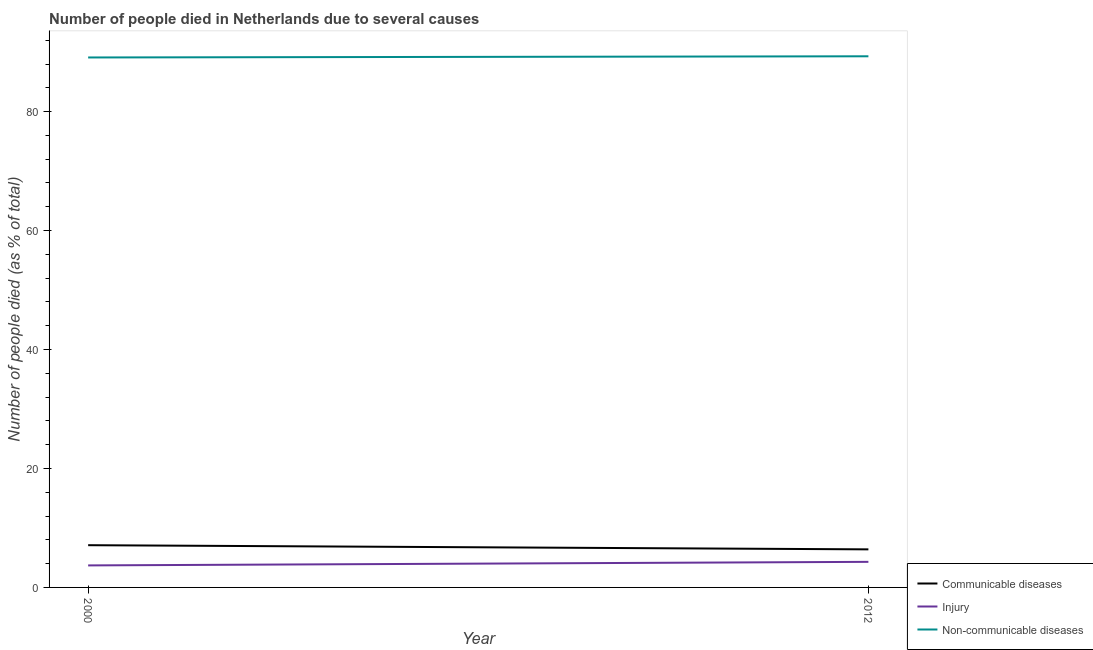How many different coloured lines are there?
Your response must be concise. 3. Is the number of lines equal to the number of legend labels?
Your response must be concise. Yes. Across all years, what is the maximum number of people who dies of non-communicable diseases?
Make the answer very short. 89.3. Across all years, what is the minimum number of people who dies of non-communicable diseases?
Give a very brief answer. 89.1. In which year was the number of people who dies of non-communicable diseases maximum?
Offer a very short reply. 2012. In which year was the number of people who died of injury minimum?
Your response must be concise. 2000. What is the total number of people who dies of non-communicable diseases in the graph?
Keep it short and to the point. 178.4. What is the difference between the number of people who dies of non-communicable diseases in 2000 and that in 2012?
Your response must be concise. -0.2. What is the difference between the number of people who died of injury in 2012 and the number of people who died of communicable diseases in 2000?
Keep it short and to the point. -2.8. What is the average number of people who died of communicable diseases per year?
Your response must be concise. 6.75. In the year 2000, what is the difference between the number of people who died of injury and number of people who died of communicable diseases?
Your response must be concise. -3.4. What is the ratio of the number of people who dies of non-communicable diseases in 2000 to that in 2012?
Provide a short and direct response. 1. Is the number of people who died of injury in 2000 less than that in 2012?
Offer a very short reply. Yes. In how many years, is the number of people who died of communicable diseases greater than the average number of people who died of communicable diseases taken over all years?
Your answer should be very brief. 1. Is it the case that in every year, the sum of the number of people who died of communicable diseases and number of people who died of injury is greater than the number of people who dies of non-communicable diseases?
Your answer should be compact. No. What is the difference between two consecutive major ticks on the Y-axis?
Keep it short and to the point. 20. Does the graph contain any zero values?
Provide a succinct answer. No. Where does the legend appear in the graph?
Provide a short and direct response. Bottom right. How are the legend labels stacked?
Your response must be concise. Vertical. What is the title of the graph?
Your answer should be compact. Number of people died in Netherlands due to several causes. What is the label or title of the Y-axis?
Give a very brief answer. Number of people died (as % of total). What is the Number of people died (as % of total) in Communicable diseases in 2000?
Your answer should be very brief. 7.1. What is the Number of people died (as % of total) of Non-communicable diseases in 2000?
Your answer should be compact. 89.1. What is the Number of people died (as % of total) of Injury in 2012?
Your answer should be very brief. 4.3. What is the Number of people died (as % of total) of Non-communicable diseases in 2012?
Keep it short and to the point. 89.3. Across all years, what is the maximum Number of people died (as % of total) in Non-communicable diseases?
Provide a succinct answer. 89.3. Across all years, what is the minimum Number of people died (as % of total) in Communicable diseases?
Give a very brief answer. 6.4. Across all years, what is the minimum Number of people died (as % of total) of Injury?
Your response must be concise. 3.7. Across all years, what is the minimum Number of people died (as % of total) of Non-communicable diseases?
Ensure brevity in your answer.  89.1. What is the total Number of people died (as % of total) in Non-communicable diseases in the graph?
Your answer should be compact. 178.4. What is the difference between the Number of people died (as % of total) in Injury in 2000 and that in 2012?
Give a very brief answer. -0.6. What is the difference between the Number of people died (as % of total) of Non-communicable diseases in 2000 and that in 2012?
Your answer should be very brief. -0.2. What is the difference between the Number of people died (as % of total) in Communicable diseases in 2000 and the Number of people died (as % of total) in Non-communicable diseases in 2012?
Make the answer very short. -82.2. What is the difference between the Number of people died (as % of total) in Injury in 2000 and the Number of people died (as % of total) in Non-communicable diseases in 2012?
Ensure brevity in your answer.  -85.6. What is the average Number of people died (as % of total) in Communicable diseases per year?
Provide a short and direct response. 6.75. What is the average Number of people died (as % of total) of Injury per year?
Provide a short and direct response. 4. What is the average Number of people died (as % of total) of Non-communicable diseases per year?
Provide a succinct answer. 89.2. In the year 2000, what is the difference between the Number of people died (as % of total) in Communicable diseases and Number of people died (as % of total) in Non-communicable diseases?
Offer a very short reply. -82. In the year 2000, what is the difference between the Number of people died (as % of total) in Injury and Number of people died (as % of total) in Non-communicable diseases?
Give a very brief answer. -85.4. In the year 2012, what is the difference between the Number of people died (as % of total) of Communicable diseases and Number of people died (as % of total) of Non-communicable diseases?
Your answer should be compact. -82.9. In the year 2012, what is the difference between the Number of people died (as % of total) in Injury and Number of people died (as % of total) in Non-communicable diseases?
Your answer should be very brief. -85. What is the ratio of the Number of people died (as % of total) of Communicable diseases in 2000 to that in 2012?
Offer a very short reply. 1.11. What is the ratio of the Number of people died (as % of total) of Injury in 2000 to that in 2012?
Offer a very short reply. 0.86. What is the ratio of the Number of people died (as % of total) in Non-communicable diseases in 2000 to that in 2012?
Make the answer very short. 1. What is the difference between the highest and the second highest Number of people died (as % of total) in Injury?
Give a very brief answer. 0.6. What is the difference between the highest and the second highest Number of people died (as % of total) in Non-communicable diseases?
Your answer should be compact. 0.2. What is the difference between the highest and the lowest Number of people died (as % of total) of Communicable diseases?
Make the answer very short. 0.7. What is the difference between the highest and the lowest Number of people died (as % of total) in Injury?
Give a very brief answer. 0.6. 